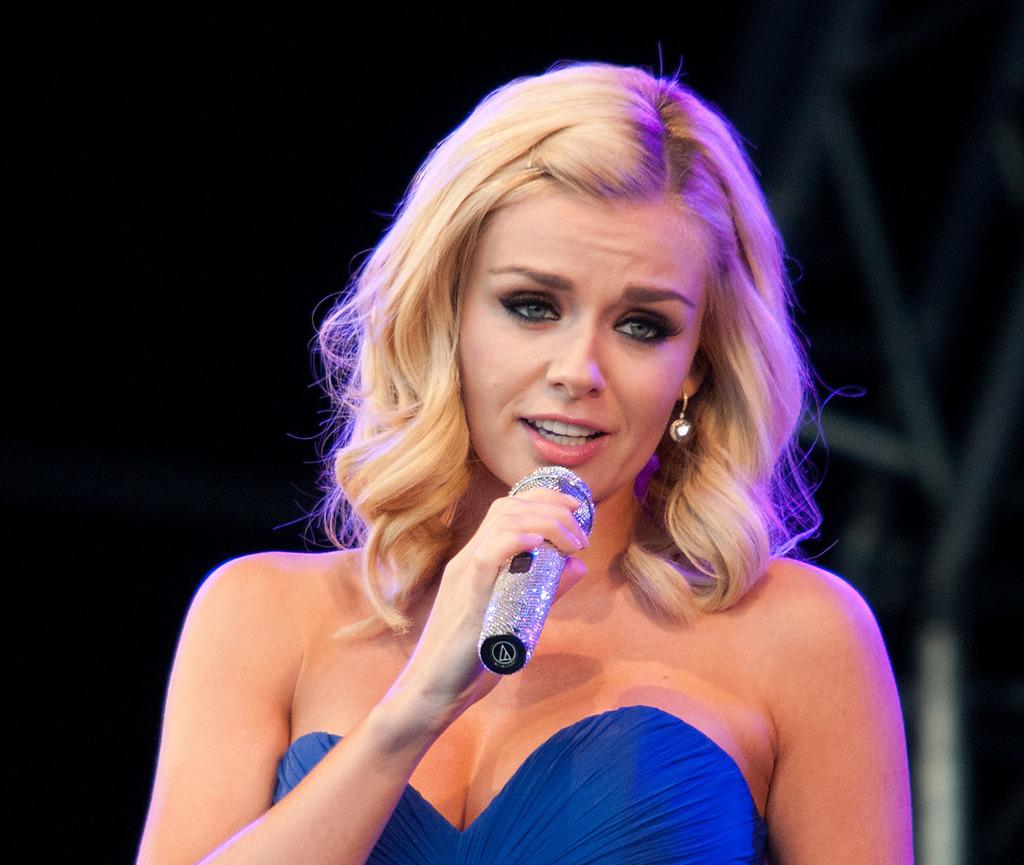What is the main subject of the image? The main subject of the image is a woman. What is the woman doing in the image? The woman is talking in the image. How is the woman communicating in the image? The woman is using a microphone to talk in the image. What type of art can be seen hanging on the trees in the image? There are no trees or art present in the image; it features a woman talking with a microphone. 